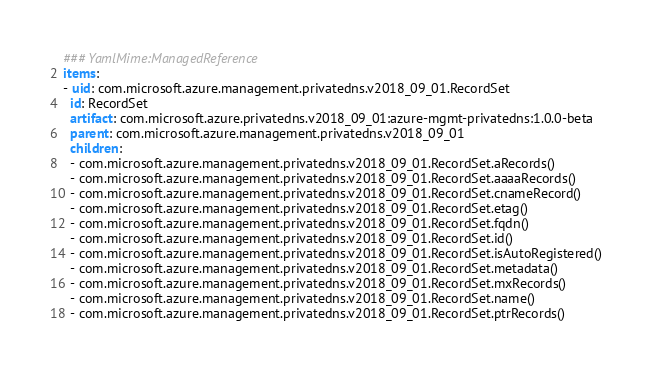Convert code to text. <code><loc_0><loc_0><loc_500><loc_500><_YAML_>### YamlMime:ManagedReference
items:
- uid: com.microsoft.azure.management.privatedns.v2018_09_01.RecordSet
  id: RecordSet
  artifact: com.microsoft.azure.privatedns.v2018_09_01:azure-mgmt-privatedns:1.0.0-beta
  parent: com.microsoft.azure.management.privatedns.v2018_09_01
  children:
  - com.microsoft.azure.management.privatedns.v2018_09_01.RecordSet.aRecords()
  - com.microsoft.azure.management.privatedns.v2018_09_01.RecordSet.aaaaRecords()
  - com.microsoft.azure.management.privatedns.v2018_09_01.RecordSet.cnameRecord()
  - com.microsoft.azure.management.privatedns.v2018_09_01.RecordSet.etag()
  - com.microsoft.azure.management.privatedns.v2018_09_01.RecordSet.fqdn()
  - com.microsoft.azure.management.privatedns.v2018_09_01.RecordSet.id()
  - com.microsoft.azure.management.privatedns.v2018_09_01.RecordSet.isAutoRegistered()
  - com.microsoft.azure.management.privatedns.v2018_09_01.RecordSet.metadata()
  - com.microsoft.azure.management.privatedns.v2018_09_01.RecordSet.mxRecords()
  - com.microsoft.azure.management.privatedns.v2018_09_01.RecordSet.name()
  - com.microsoft.azure.management.privatedns.v2018_09_01.RecordSet.ptrRecords()</code> 